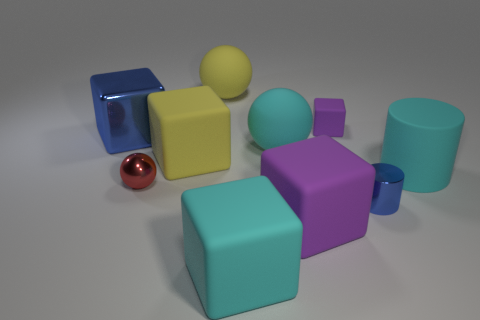Subtract all green cubes. Subtract all purple cylinders. How many cubes are left? 5 Subtract all spheres. How many objects are left? 7 Subtract 0 purple spheres. How many objects are left? 10 Subtract all large things. Subtract all large yellow rubber things. How many objects are left? 1 Add 1 large cyan matte balls. How many large cyan matte balls are left? 2 Add 2 cyan things. How many cyan things exist? 5 